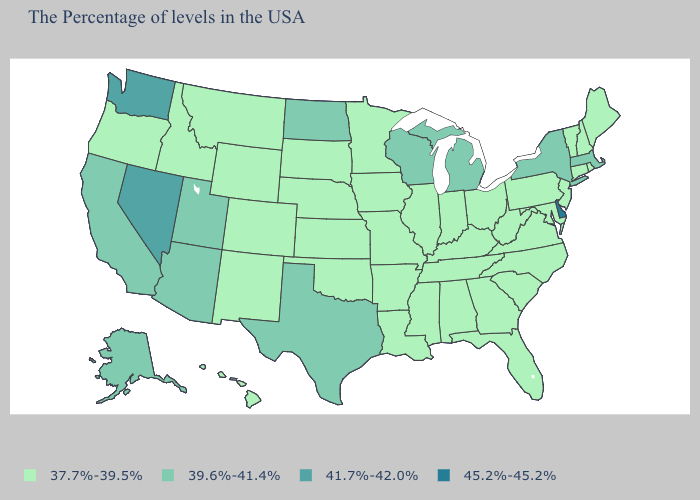Does Illinois have a lower value than Utah?
Write a very short answer. Yes. Does California have the lowest value in the USA?
Quick response, please. No. What is the value of Massachusetts?
Quick response, please. 39.6%-41.4%. What is the value of Colorado?
Write a very short answer. 37.7%-39.5%. What is the value of California?
Write a very short answer. 39.6%-41.4%. Name the states that have a value in the range 37.7%-39.5%?
Give a very brief answer. Maine, Rhode Island, New Hampshire, Vermont, Connecticut, New Jersey, Maryland, Pennsylvania, Virginia, North Carolina, South Carolina, West Virginia, Ohio, Florida, Georgia, Kentucky, Indiana, Alabama, Tennessee, Illinois, Mississippi, Louisiana, Missouri, Arkansas, Minnesota, Iowa, Kansas, Nebraska, Oklahoma, South Dakota, Wyoming, Colorado, New Mexico, Montana, Idaho, Oregon, Hawaii. Name the states that have a value in the range 41.7%-42.0%?
Quick response, please. Nevada, Washington. Name the states that have a value in the range 41.7%-42.0%?
Write a very short answer. Nevada, Washington. Among the states that border Wyoming , does Montana have the highest value?
Write a very short answer. No. What is the highest value in states that border Maryland?
Answer briefly. 45.2%-45.2%. What is the lowest value in the South?
Short answer required. 37.7%-39.5%. Does Delaware have the highest value in the USA?
Keep it brief. Yes. Name the states that have a value in the range 41.7%-42.0%?
Give a very brief answer. Nevada, Washington. Does Washington have the lowest value in the USA?
Keep it brief. No. 